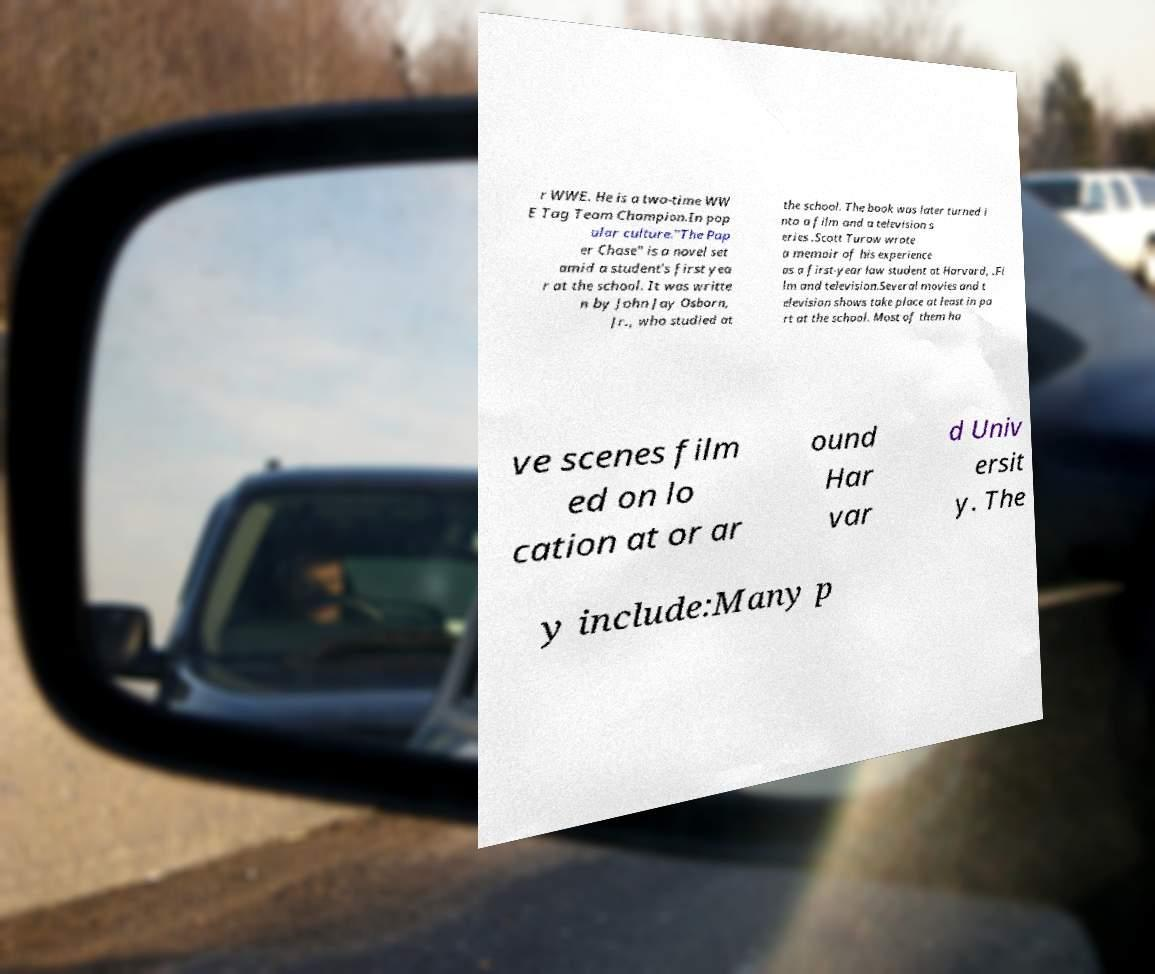I need the written content from this picture converted into text. Can you do that? r WWE. He is a two-time WW E Tag Team Champion.In pop ular culture."The Pap er Chase" is a novel set amid a student's first yea r at the school. It was writte n by John Jay Osborn, Jr., who studied at the school. The book was later turned i nto a film and a television s eries .Scott Turow wrote a memoir of his experience as a first-year law student at Harvard, .Fi lm and television.Several movies and t elevision shows take place at least in pa rt at the school. Most of them ha ve scenes film ed on lo cation at or ar ound Har var d Univ ersit y. The y include:Many p 